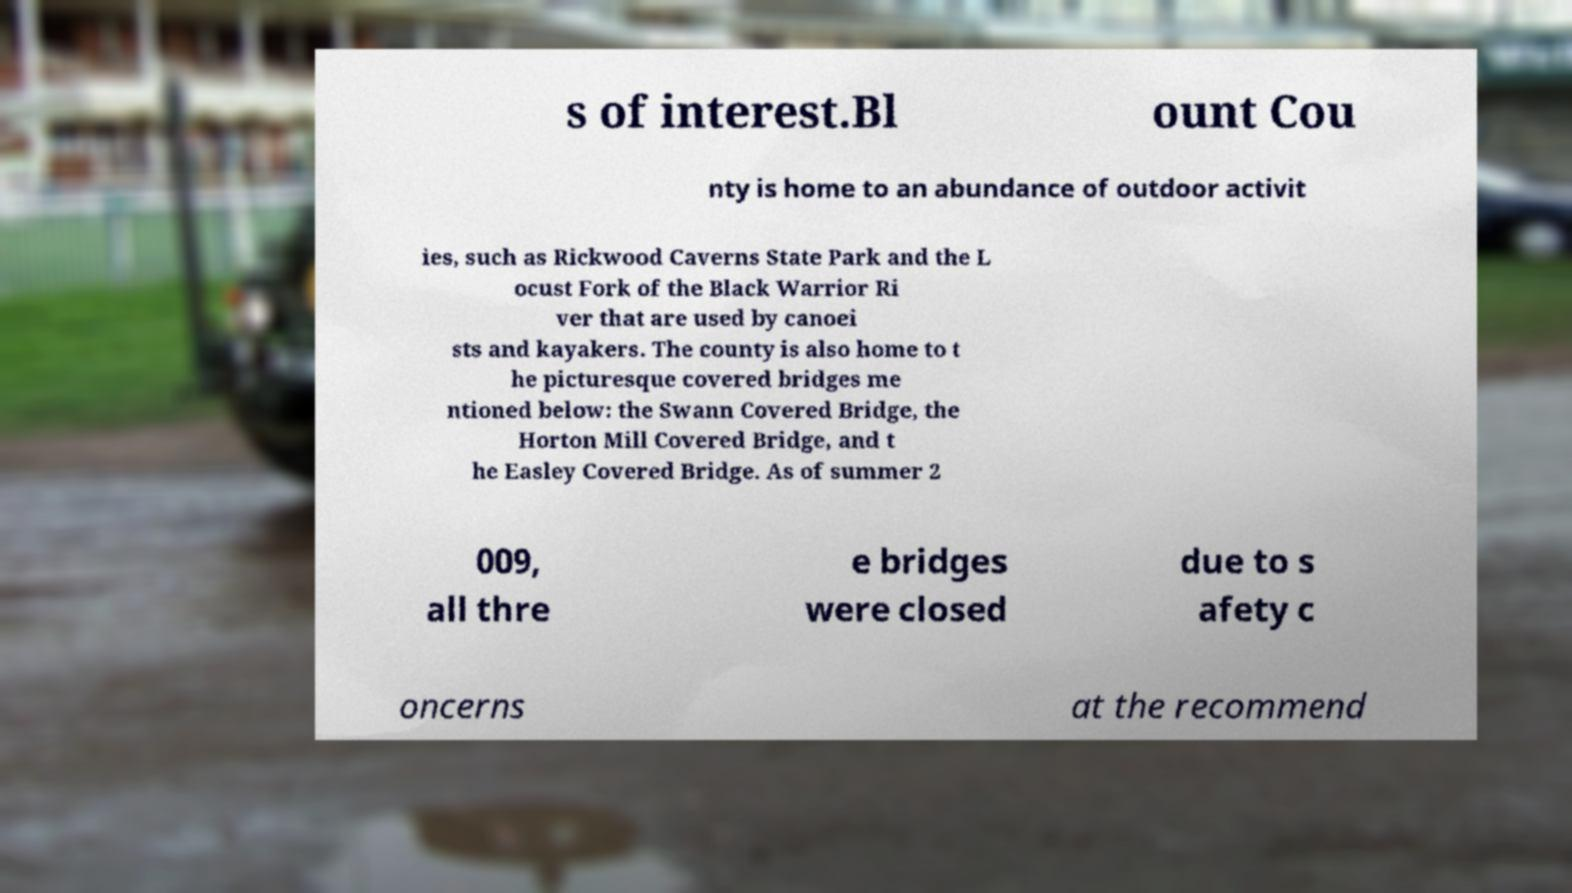Could you extract and type out the text from this image? s of interest.Bl ount Cou nty is home to an abundance of outdoor activit ies, such as Rickwood Caverns State Park and the L ocust Fork of the Black Warrior Ri ver that are used by canoei sts and kayakers. The county is also home to t he picturesque covered bridges me ntioned below: the Swann Covered Bridge, the Horton Mill Covered Bridge, and t he Easley Covered Bridge. As of summer 2 009, all thre e bridges were closed due to s afety c oncerns at the recommend 